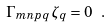<formula> <loc_0><loc_0><loc_500><loc_500>\Gamma _ { m n p q } \, \zeta _ { q } = 0 \ .</formula> 